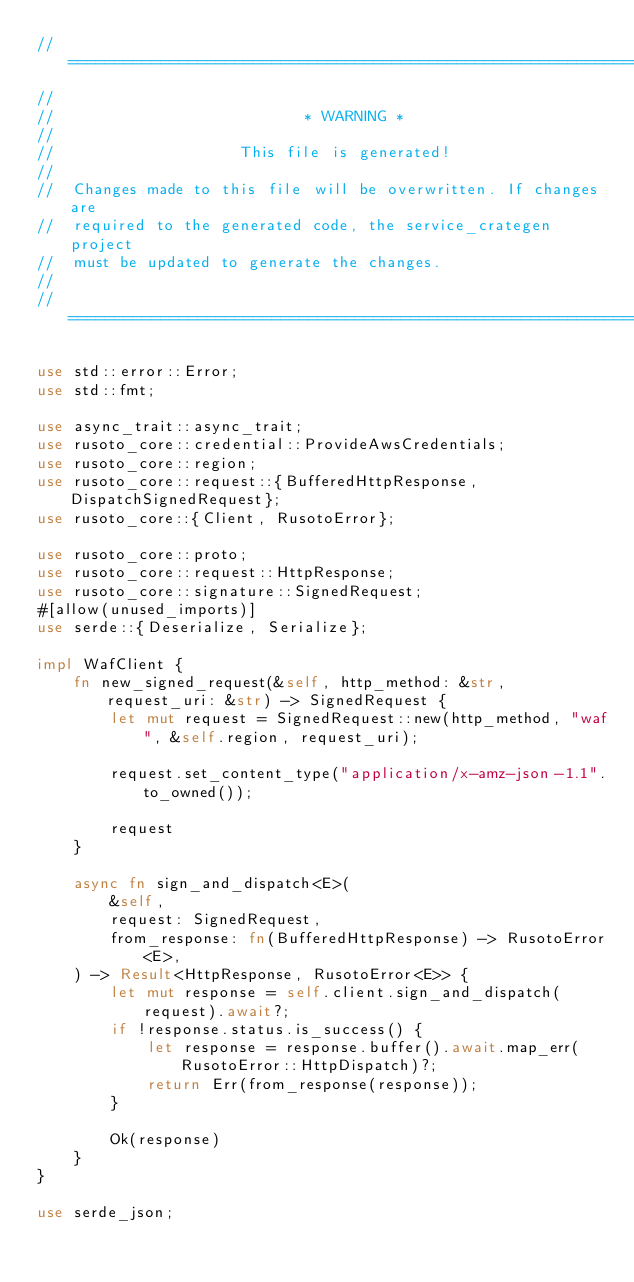<code> <loc_0><loc_0><loc_500><loc_500><_Rust_>// =================================================================
//
//                           * WARNING *
//
//                    This file is generated!
//
//  Changes made to this file will be overwritten. If changes are
//  required to the generated code, the service_crategen project
//  must be updated to generate the changes.
//
// =================================================================

use std::error::Error;
use std::fmt;

use async_trait::async_trait;
use rusoto_core::credential::ProvideAwsCredentials;
use rusoto_core::region;
use rusoto_core::request::{BufferedHttpResponse, DispatchSignedRequest};
use rusoto_core::{Client, RusotoError};

use rusoto_core::proto;
use rusoto_core::request::HttpResponse;
use rusoto_core::signature::SignedRequest;
#[allow(unused_imports)]
use serde::{Deserialize, Serialize};

impl WafClient {
    fn new_signed_request(&self, http_method: &str, request_uri: &str) -> SignedRequest {
        let mut request = SignedRequest::new(http_method, "waf", &self.region, request_uri);

        request.set_content_type("application/x-amz-json-1.1".to_owned());

        request
    }

    async fn sign_and_dispatch<E>(
        &self,
        request: SignedRequest,
        from_response: fn(BufferedHttpResponse) -> RusotoError<E>,
    ) -> Result<HttpResponse, RusotoError<E>> {
        let mut response = self.client.sign_and_dispatch(request).await?;
        if !response.status.is_success() {
            let response = response.buffer().await.map_err(RusotoError::HttpDispatch)?;
            return Err(from_response(response));
        }

        Ok(response)
    }
}

use serde_json;</code> 